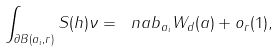Convert formula to latex. <formula><loc_0><loc_0><loc_500><loc_500>\int _ { \partial B ( a _ { i } , r ) } S ( h ) \nu = \ n a b _ { a _ { i } } W _ { d } ( a ) + o _ { r } ( 1 ) ,</formula> 